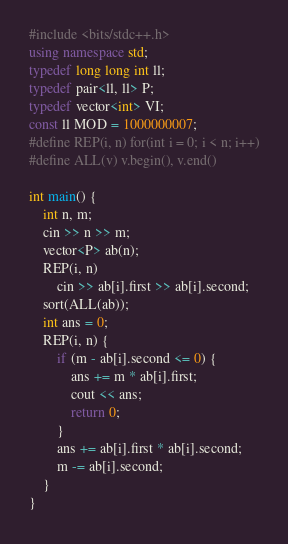<code> <loc_0><loc_0><loc_500><loc_500><_C++_>#include <bits/stdc++.h>
using namespace std;
typedef long long int ll;
typedef pair<ll, ll> P;
typedef vector<int> VI;
const ll MOD = 1000000007;
#define REP(i, n) for(int i = 0; i < n; i++)
#define ALL(v) v.begin(), v.end()

int main() {
	int n, m;
	cin >> n >> m;
	vector<P> ab(n);
	REP(i, n)
		cin >> ab[i].first >> ab[i].second;
	sort(ALL(ab));
	int ans = 0;
	REP(i, n) {
		if (m - ab[i].second <= 0) {
			ans += m * ab[i].first;
			cout << ans;
			return 0;
		}
		ans += ab[i].first * ab[i].second;
		m -= ab[i].second;
	}
}</code> 